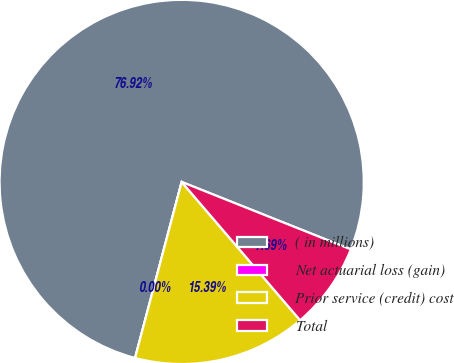Convert chart. <chart><loc_0><loc_0><loc_500><loc_500><pie_chart><fcel>( in millions)<fcel>Net actuarial loss (gain)<fcel>Prior service (credit) cost<fcel>Total<nl><fcel>76.92%<fcel>0.0%<fcel>15.39%<fcel>7.69%<nl></chart> 